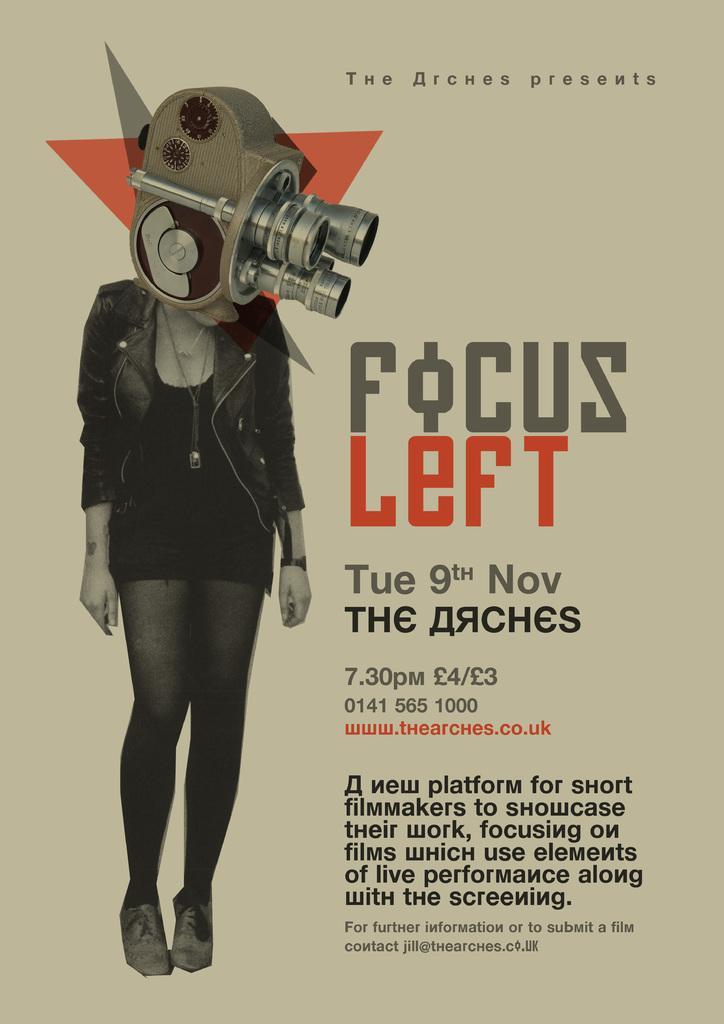Describe this image in one or two sentences. In this image I can see the person standing and I can also see the machine and I can see some is written on the image. 